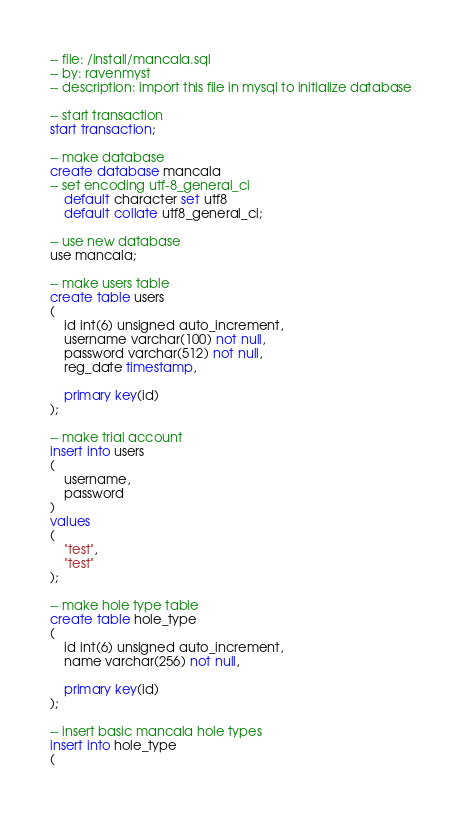<code> <loc_0><loc_0><loc_500><loc_500><_SQL_>-- file: /install/mancala.sql
-- by: ravenmyst
-- description: import this file in mysql to initialize database

-- start transaction
start transaction;

-- make database
create database mancala
-- set encoding utf-8_general_ci
    default character set utf8
    default collate utf8_general_ci;

-- use new database
use mancala;

-- make users table
create table users 
(
    id int(6) unsigned auto_increment,
    username varchar(100) not null,
    password varchar(512) not null,
    reg_date timestamp,

    primary key(id)
);

-- make trial account
insert into users 
( 
    username, 
    password
) 
values 
( 
    "test", 
    "test"
);

-- make hole type table
create table hole_type 
(
    id int(6) unsigned auto_increment,
    name varchar(256) not null,

    primary key(id)
);

-- insert basic mancala hole types
insert into hole_type 
( </code> 